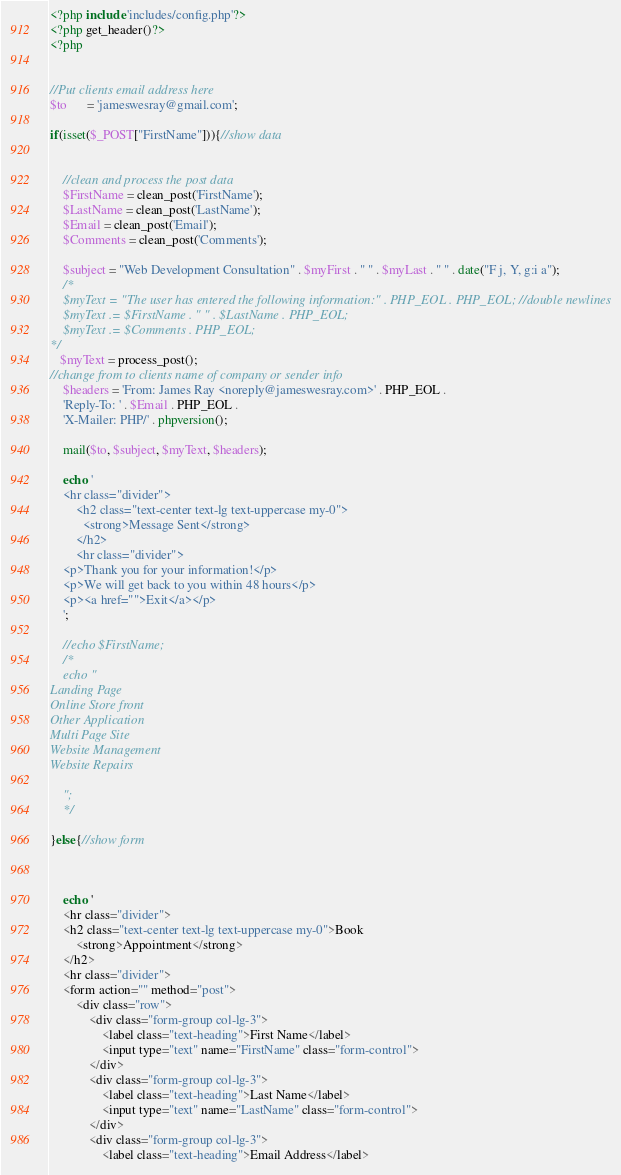<code> <loc_0><loc_0><loc_500><loc_500><_PHP_><?php include 'includes/config.php'?>
<?php get_header()?>
<?php

    
//Put clients email address here 
$to      = 'jameswesray@gmail.com';    

if(isset($_POST["FirstName"])){//show data

    
    //clean and process the post data
    $FirstName = clean_post('FirstName');
    $LastName = clean_post('LastName');
    $Email = clean_post('Email');
    $Comments = clean_post('Comments');
   
    $subject = "Web Development Consultation" . $myFirst . " " . $myLast . " " . date("F j, Y, g:i a");
    /*
    $myText = "The user has entered the following information:" . PHP_EOL . PHP_EOL; //double newlines 
    $myText .= $FirstName . " " . $LastName . PHP_EOL;
    $myText .= $Comments . PHP_EOL;
*/
   $myText = process_post();
//change from to clients name of company or sender info
    $headers = 'From: James Ray <noreply@jameswesray.com>' . PHP_EOL .
    'Reply-To: ' . $Email . PHP_EOL .
    'X-Mailer: PHP/' . phpversion();

    mail($to, $subject, $myText, $headers);
    
    echo '
    <hr class="divider"> 
        <h2 class="text-center text-lg text-uppercase my-0">
          <strong>Message Sent</strong>
        </h2>
        <hr class="divider">
    <p>Thank you for your information!</p>
    <p>We will get back to you within 48 hours</p>
    <p><a href="">Exit</a></p>
    ';
    
	//echo $FirstName;
	/*
    echo "
Landing Page
Online Store front
Other Application
Multi Page Site
Website Management
Website Repairs

	";
    */

}else{//show form
 


    echo '
    <hr class="divider">
    <h2 class="text-center text-lg text-uppercase my-0">Book
        <strong>Appointment</strong>
    </h2>
    <hr class="divider">
    <form action="" method="post">
        <div class="row">
            <div class="form-group col-lg-3">
                <label class="text-heading">First Name</label>
                <input type="text" name="FirstName" class="form-control">
            </div>
            <div class="form-group col-lg-3">
                <label class="text-heading">Last Name</label>
                <input type="text" name="LastName" class="form-control">
            </div>
            <div class="form-group col-lg-3">
                <label class="text-heading">Email Address</label></code> 